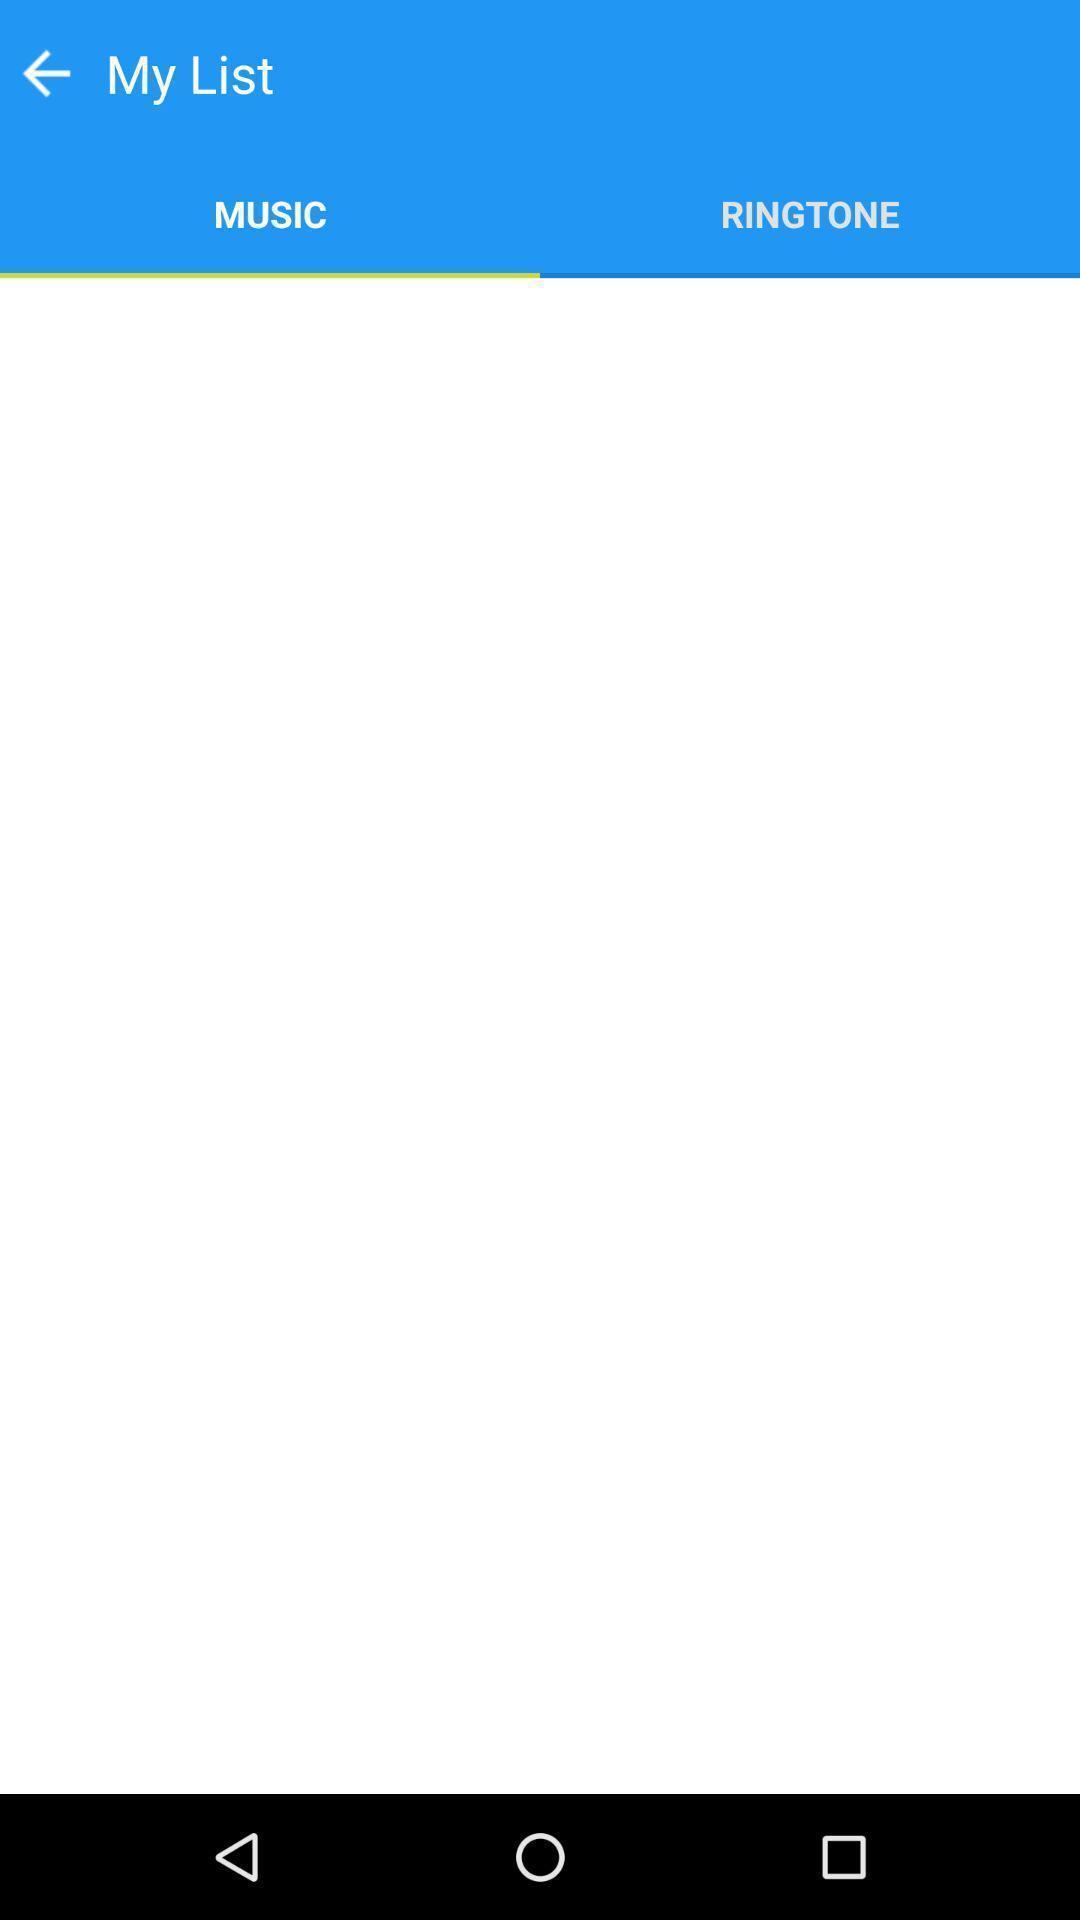Summarize the main components in this picture. Page showing your music list. 